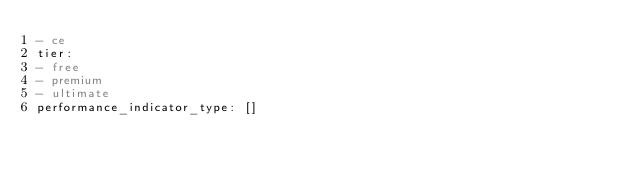<code> <loc_0><loc_0><loc_500><loc_500><_YAML_>- ce
tier:
- free
- premium
- ultimate
performance_indicator_type: []
</code> 